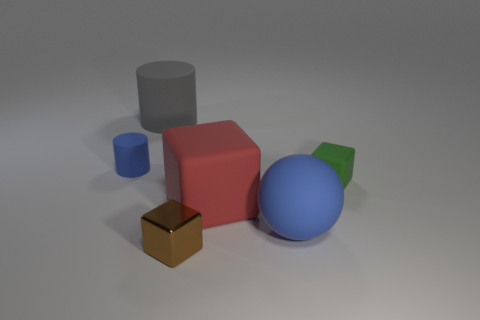What could be the purpose of arranging these items like this? This kind of arrangement is typical in a render used to demonstrate 3D modeling or lighting within a virtual environment. It allows viewers to observe the effects of light and shadow on different colored surfaces and geometric shapes. As such, it could be educational for those learning about computer graphics or merely aesthetically pleasing for those who appreciate minimalist compositions. What might this say about texture and material? The smoothness and lack of texture on the shapes suggest they might be made of a matte plastic or a similar synthetic material. Without visible textures or complex reflections, the focus is placed on the simple interplay of light and color, contributing to a very clean and idealized representation that emphasizes form and spatial relationships over material properties. 